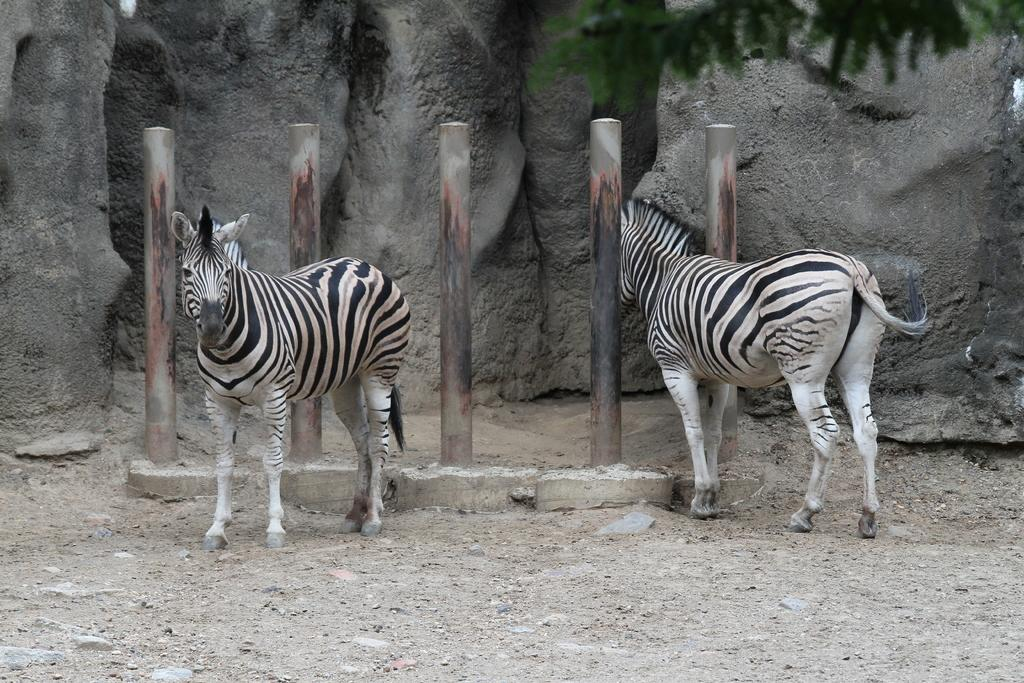How many zebras are present in the image? There are two zebras in the image. What else can be seen in the image besides the zebras? There are rods visible in the image. What type of surface is visible in the background of the image? There is a stone surface in the background of the image. What is visible at the bottom of the image? There is ground visible at the bottom of the image. What type of boot can be seen on the zebra's nose in the image? There is no boot or zebra's nose present in the image; it features two zebras and rods. How many nails are visible in the image? There are no nails visible in the image. 